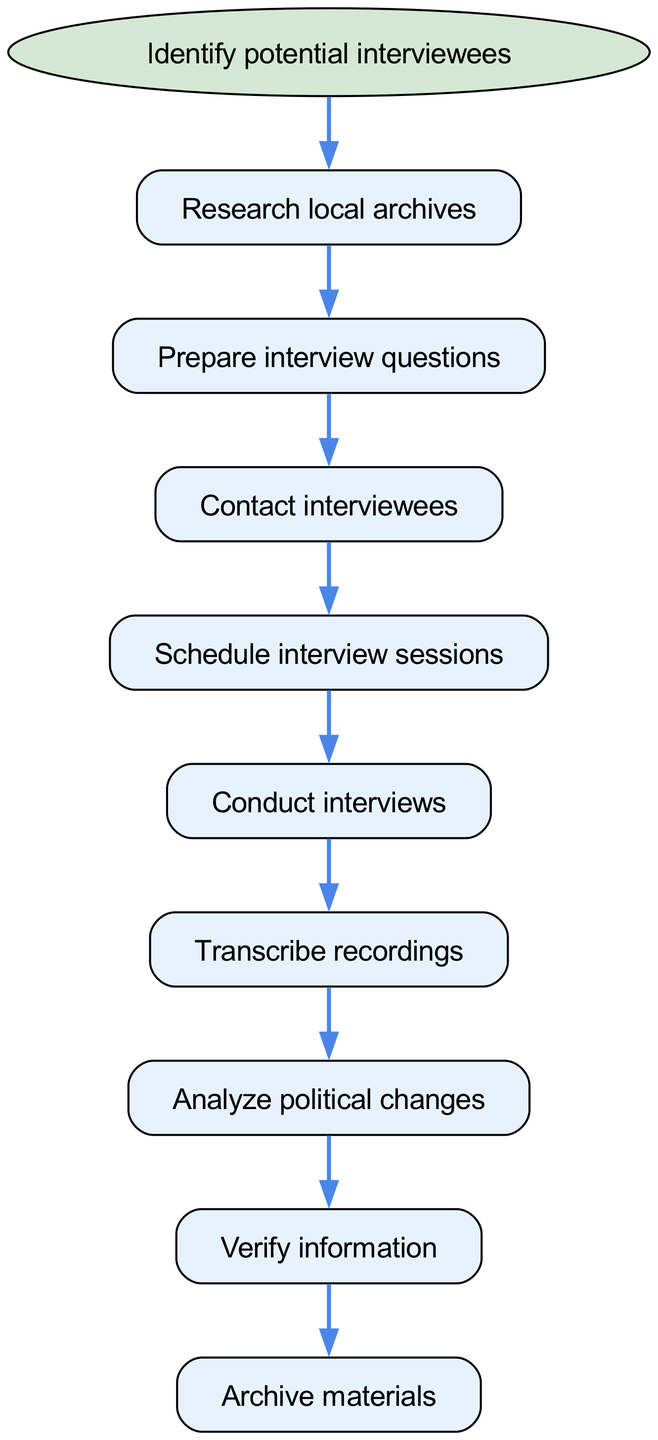What is the starting point of the workflow? The starting point of the workflow is indicated by the 'Identify potential interviewees' node, which is represented as an ellipse in the diagram. This serves as the initial step before proceeding to any further actions.
Answer: Identify potential interviewees How many nodes are in the diagram? By counting all the individual nodes present, including the starting point, there are a total of 9 nodes present in the workflow.
Answer: 9 What is the last step of the workflow? The last step of the workflow is represented by the 'Archive materials' node, which indicates the final action after verifying the interview information.
Answer: Archive materials Which node comes directly after conducting interviews? The node that follows 'Conduct interviews' is 'Transcribe recordings', indicating that transcription is the next step in the workflow after the interviews.
Answer: Transcribe recordings What is the relationship between 'Research local archives' and 'Prepare interview questions'? The relationship is a directed edge from 'Research local archives' to 'Prepare interview questions', showing that preparing the questions follows researching the archives.
Answer: Prepare interview questions How many edges are in the workflow? The number of edges can be determined by counting the directional connections between the nodes. There are 8 edges representing the flow from one step to another.
Answer: 8 Which interview preparation step involves reaching out to potential participants? The step that involves reaching out to potential participants is 'Contact interviewees', which occurs after preparing the questions.
Answer: Contact interviewees What is the role of the 'Verify information' node in the workflow? The 'Verify information' node serves to ensure that the details gathered during the interviews are accurate before archiving the materials, acting as a quality control step.
Answer: Quality control step What comes before 'Analyze political changes'? The process that comes just before 'Analyze political changes' is 'Transcribe recordings', which allows for a review of the interview content before analysis begins.
Answer: Transcribe recordings 